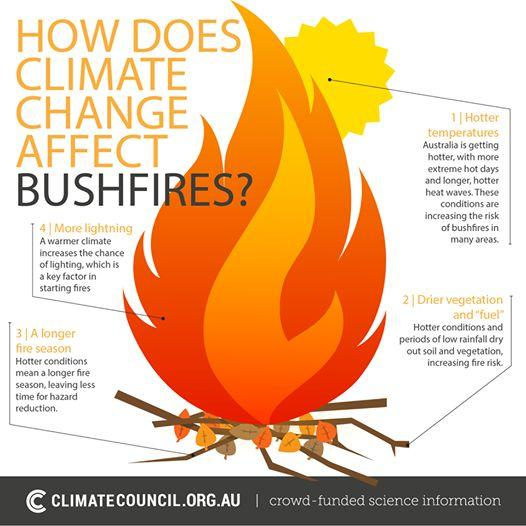Indicate a few pertinent items in this graphic. A longer fire season results in less time for hazard reduction. The increasing risk of bushfires in many areas of Australia is due to the hotter temperatures. 